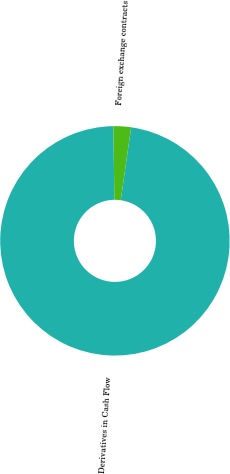<chart> <loc_0><loc_0><loc_500><loc_500><pie_chart><fcel>Derivatives in Cash Flow<fcel>Foreign exchange contracts<nl><fcel>97.53%<fcel>2.47%<nl></chart> 